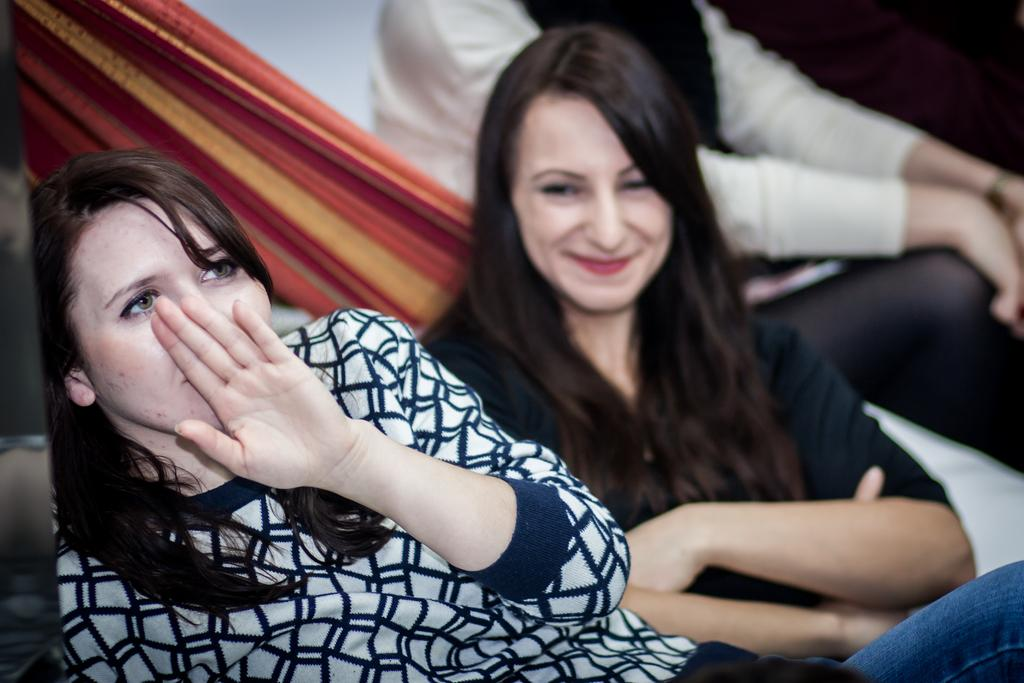How many women are seated in the image? There are two women seated in the image. What is the facial expression of one of the women? One of the women is smiling. Where is the third woman seated in relation to the other two? There is no third woman seated; there are only two women in the image. What is one of the women doing with her hand? One of the women is covering her face with her hand. What type of sticks are being used by the women in the image? There are no sticks present in the image; the women are not using any sticks. 